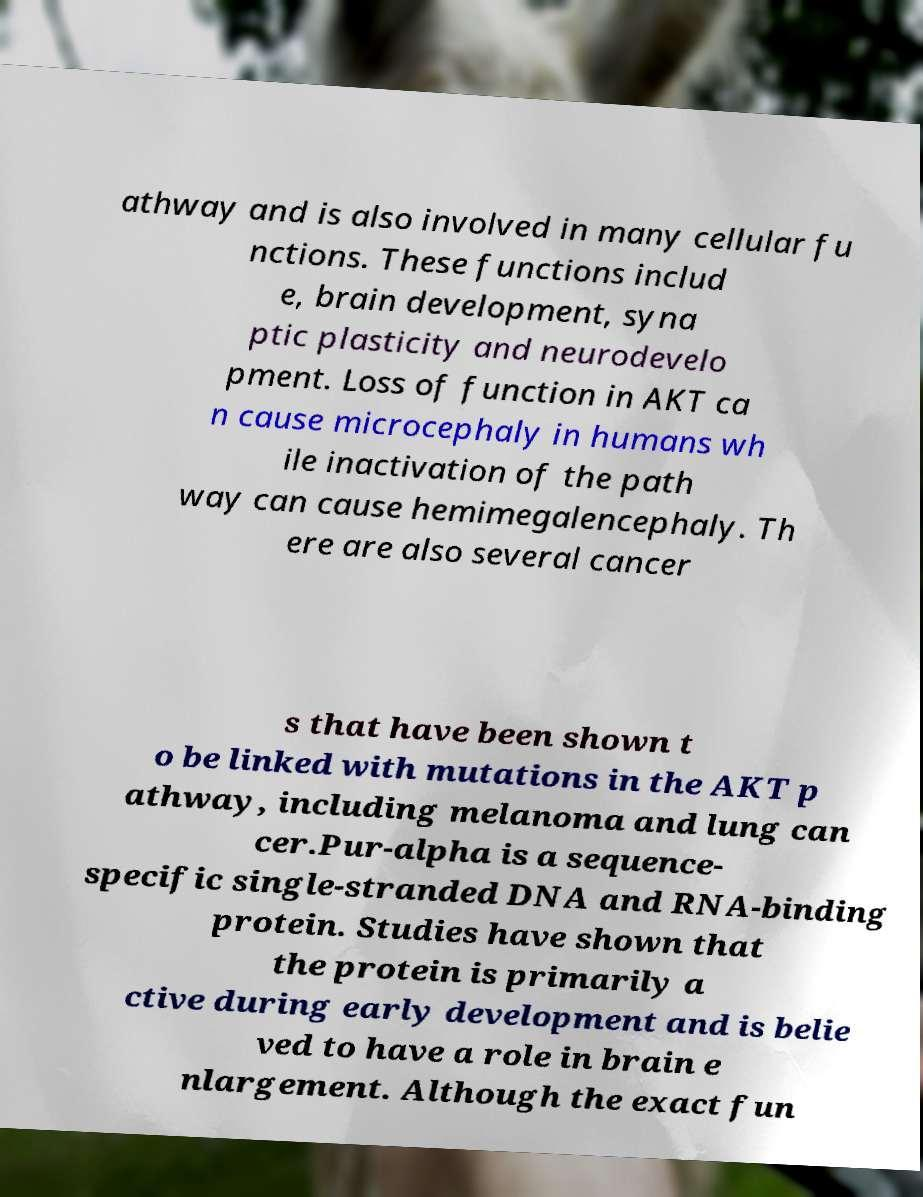Please read and relay the text visible in this image. What does it say? athway and is also involved in many cellular fu nctions. These functions includ e, brain development, syna ptic plasticity and neurodevelo pment. Loss of function in AKT ca n cause microcephaly in humans wh ile inactivation of the path way can cause hemimegalencephaly. Th ere are also several cancer s that have been shown t o be linked with mutations in the AKT p athway, including melanoma and lung can cer.Pur-alpha is a sequence- specific single-stranded DNA and RNA-binding protein. Studies have shown that the protein is primarily a ctive during early development and is belie ved to have a role in brain e nlargement. Although the exact fun 